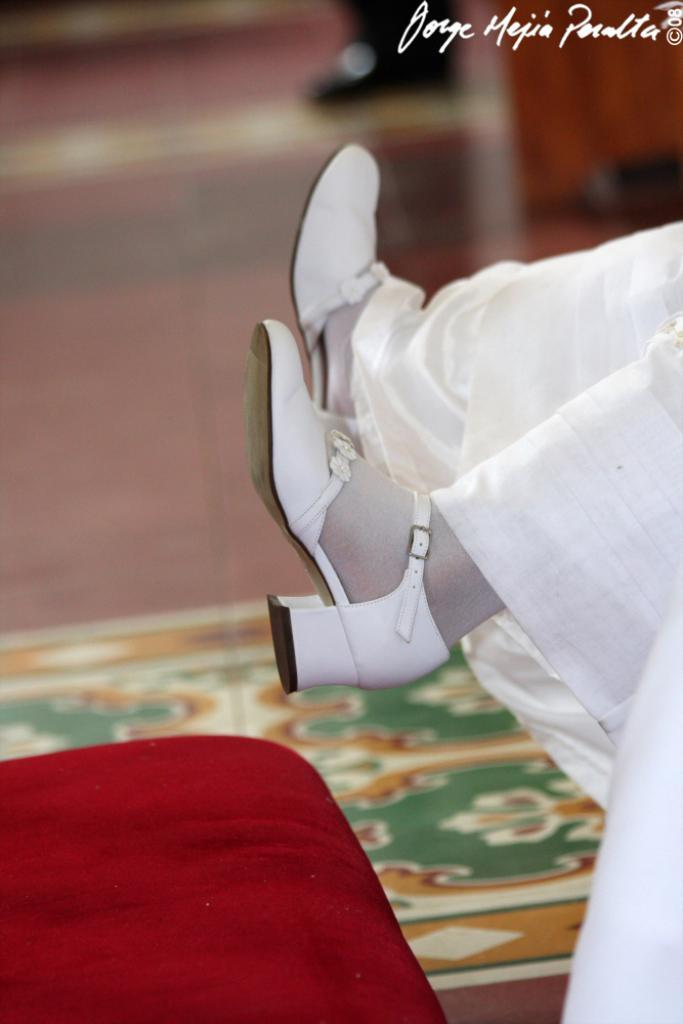What part of a person's body is visible in the image? There is a person's leg in the image. What color is the object in the image? There is a red color object in the image. Where is the text located in the image? The text is at the top of the image. How many chickens are present in the image? There are no chickens present in the image. Is there a crown visible on the person's leg in the image? There is no crown visible in the image. 